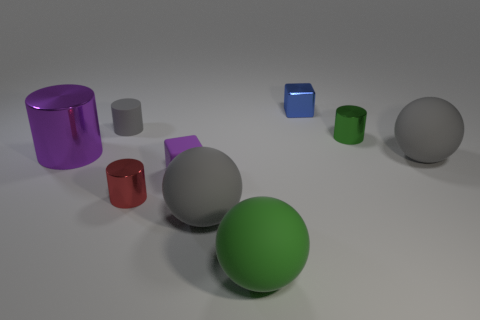What is the texture like on the objects, and how do they appear to be lit? All objects in the image have a smooth, reflective surface suggesting a metallic or plastic material. They are lit with diffused lighting that creates soft shadows, giving a sense of depth and realism to the scene. 